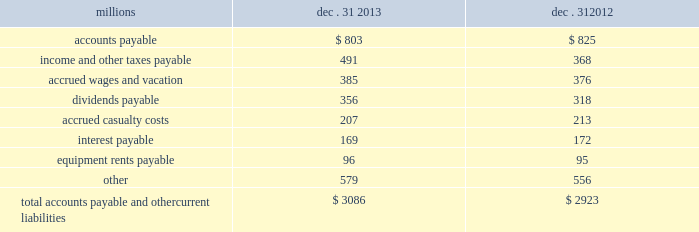The analysis of our depreciation studies .
Changes in the estimated service lives of our assets and their related depreciation rates are implemented prospectively .
Under group depreciation , the historical cost ( net of salvage ) of depreciable property that is retired or replaced in the ordinary course of business is charged to accumulated depreciation and no gain or loss is recognized .
The historical cost of certain track assets is estimated using ( i ) inflation indices published by the bureau of labor statistics and ( ii ) the estimated useful lives of the assets as determined by our depreciation studies .
The indices were selected because they closely correlate with the major costs of the properties comprising the applicable track asset classes .
Because of the number of estimates inherent in the depreciation and retirement processes and because it is impossible to precisely estimate each of these variables until a group of property is completely retired , we continually monitor the estimated service lives of our assets and the accumulated depreciation associated with each asset class to ensure our depreciation rates are appropriate .
In addition , we determine if the recorded amount of accumulated depreciation is deficient ( or in excess ) of the amount indicated by our depreciation studies .
Any deficiency ( or excess ) is amortized as a component of depreciation expense over the remaining service lives of the applicable classes of assets .
For retirements of depreciable railroad properties that do not occur in the normal course of business , a gain or loss may be recognized if the retirement meets each of the following three conditions : ( i ) is unusual , ( ii ) is material in amount , and ( iii ) varies significantly from the retirement profile identified through our depreciation studies .
A gain or loss is recognized in other income when we sell land or dispose of assets that are not part of our railroad operations .
When we purchase an asset , we capitalize all costs necessary to make the asset ready for its intended use .
However , many of our assets are self-constructed .
A large portion of our capital expenditures is for replacement of existing track assets and other road properties , which is typically performed by our employees , and for track line expansion and other capacity projects .
Costs that are directly attributable to capital projects ( including overhead costs ) are capitalized .
Direct costs that are capitalized as part of self- constructed assets include material , labor , and work equipment .
Indirect costs are capitalized if they clearly relate to the construction of the asset .
General and administrative expenditures are expensed as incurred .
Normal repairs and maintenance are also expensed as incurred , while costs incurred that extend the useful life of an asset , improve the safety of our operations or improve operating efficiency are capitalized .
These costs are allocated using appropriate statistical bases .
Total expense for repairs and maintenance incurred was $ 2.3 billion for 2013 , $ 2.1 billion for 2012 , and $ 2.2 billion for 2011 .
Assets held under capital leases are recorded at the lower of the net present value of the minimum lease payments or the fair value of the leased asset at the inception of the lease .
Amortization expense is computed using the straight-line method over the shorter of the estimated useful lives of the assets or the period of the related lease .
12 .
Accounts payable and other current liabilities dec .
31 , dec .
31 , millions 2013 2012 .

What was the average repairs and maintenance incurred from 2011 to 2013 in billions? 
Computations: (((2.3 + 2.1) + 2.2) / 3)
Answer: 2.2. 